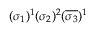<formula> <loc_0><loc_0><loc_500><loc_500>( \sigma _ { 1 } ) ^ { 1 } ( \sigma _ { 2 } ) ^ { 2 } ( \overline { { \sigma _ { 3 } } } ) ^ { 1 }</formula> 